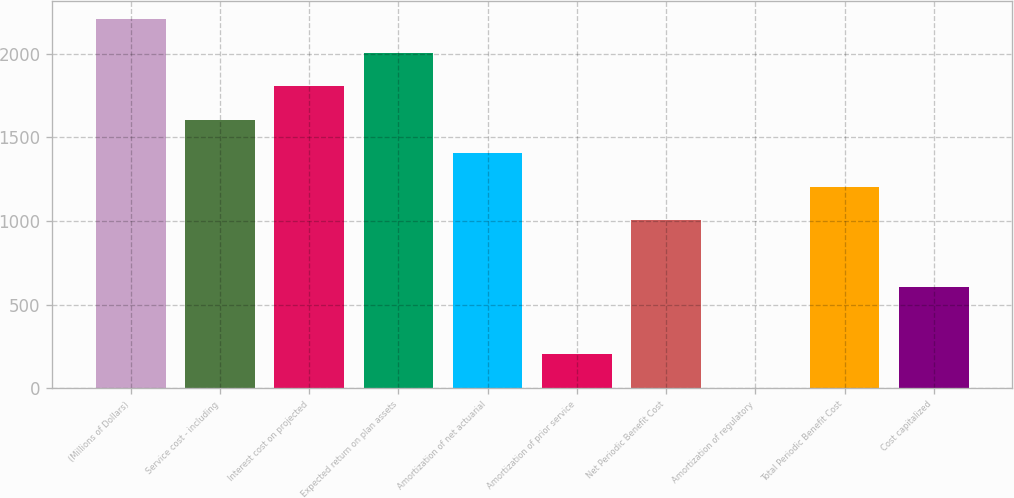Convert chart. <chart><loc_0><loc_0><loc_500><loc_500><bar_chart><fcel>(Millions of Dollars)<fcel>Service cost - including<fcel>Interest cost on projected<fcel>Expected return on plan assets<fcel>Amortization of net actuarial<fcel>Amortization of prior service<fcel>Net Periodic Benefit Cost<fcel>Amortization of regulatory<fcel>Total Periodic Benefit Cost<fcel>Cost capitalized<nl><fcel>2206.2<fcel>1605.6<fcel>1805.8<fcel>2006<fcel>1405.4<fcel>204.2<fcel>1005<fcel>4<fcel>1205.2<fcel>604.6<nl></chart> 